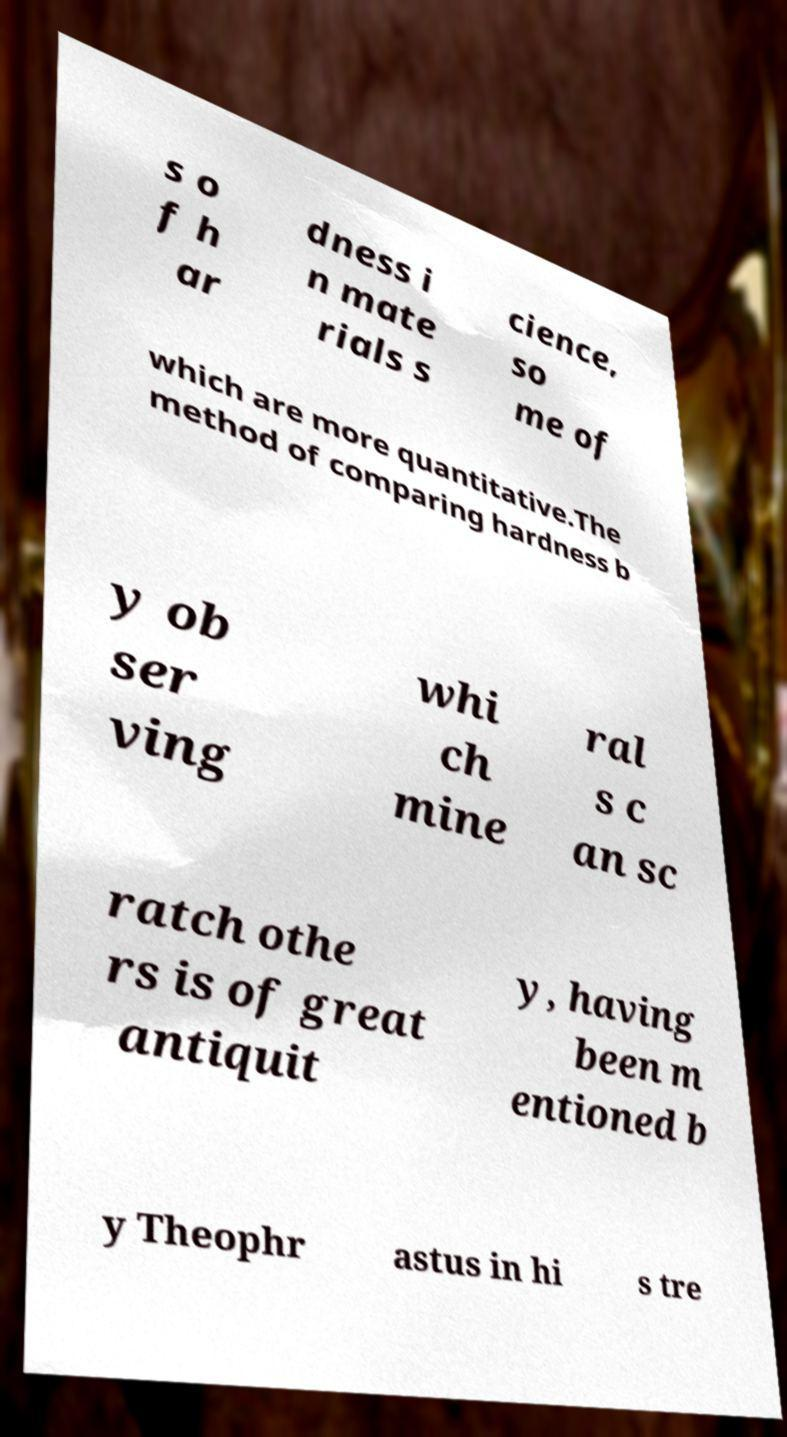What messages or text are displayed in this image? I need them in a readable, typed format. s o f h ar dness i n mate rials s cience, so me of which are more quantitative.The method of comparing hardness b y ob ser ving whi ch mine ral s c an sc ratch othe rs is of great antiquit y, having been m entioned b y Theophr astus in hi s tre 